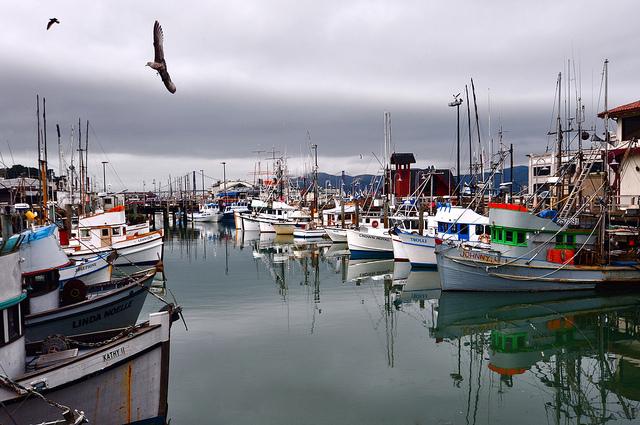Are the boats facing the same direction?
Be succinct. Yes. What is this body of water called?
Quick response, please. Bay. Is the water wavy?
Be succinct. No. What is the condition of the water?
Be succinct. Calm. 